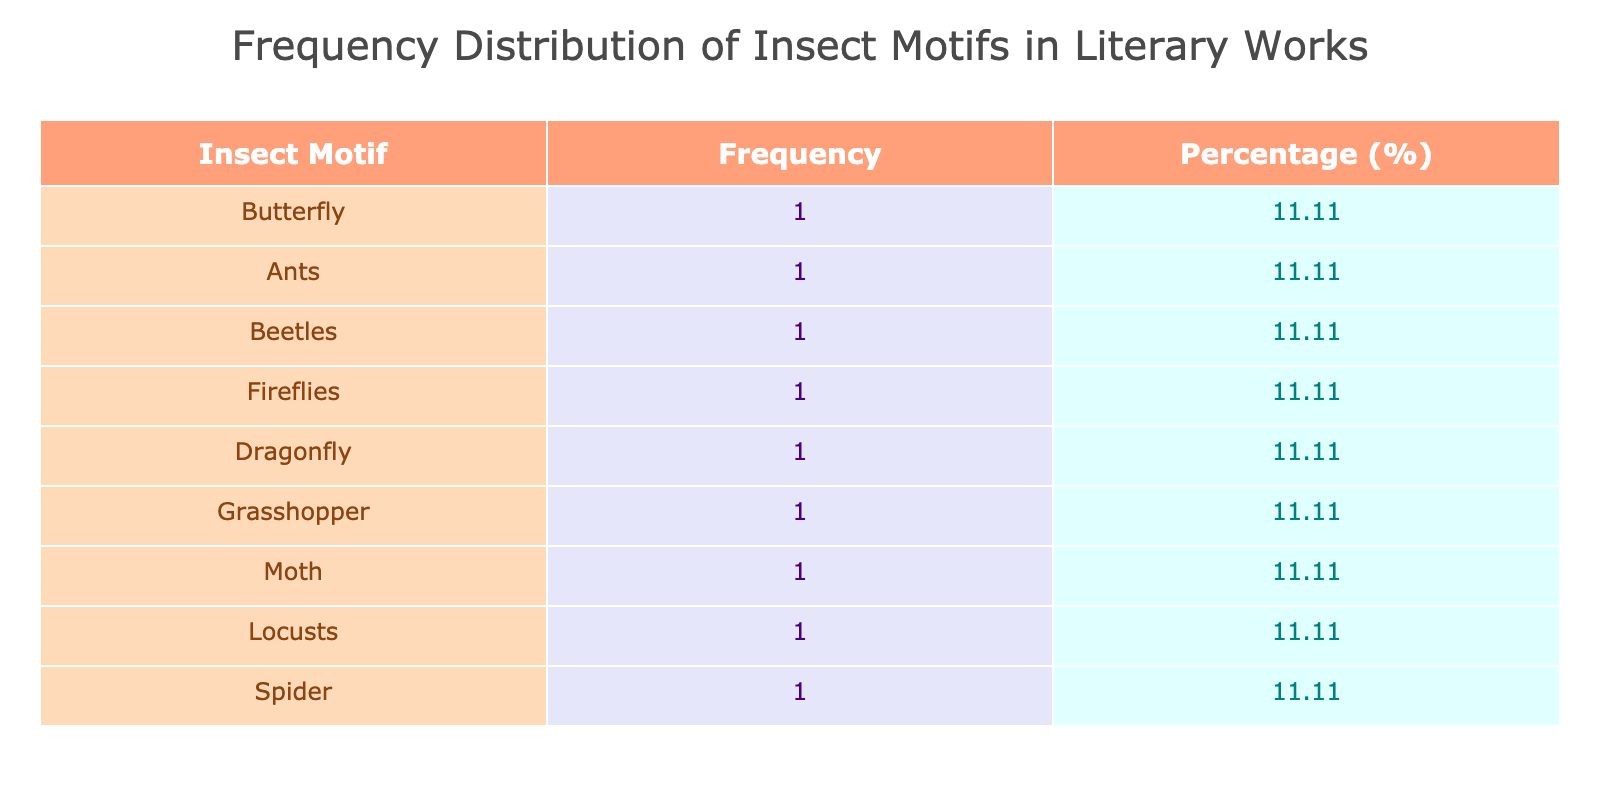What insect motif appears most frequently in literary works? By looking at the table, we can see the frequency column to identify which insect motif has the highest count. Butterfly is listed, with a frequency of 1, but it is tied with several others too.
Answer: Butterfly How many literary works feature the motif of ants? We can directly check the frequency listed for "Ants" in the frequency column. It shows that there is 1 instance of this motif in the literary works.
Answer: 1 Which insect motif is associated with the horror genre? By reviewing the genre column in conjunction with the insect motifs, we find that "Beetles" is the motif linked with the horror genre due to the relevant literary work listed.
Answer: Beetles What is the percentage of literary works that feature dragonflies? The frequency of dragonflies is 1, and the total number of works listed is 8. To get the percentage, we calculate (1/8) * 100 = 12.5%.
Answer: 12.5% Was there any literary work published before 1900 that includes insect motifs? Reviewing the publication year column reveals that "The Beetle" published in 1897 features an insect motif, confirming that works did exist before 1900.
Answer: Yes What is the cumulative frequency of works featuring butterflies and moths? The frequency for "Butterfly" is 1 and for "Moth" is also 1. By adding these frequencies together, we see that the cumulative frequency is 1 + 1 = 2.
Answer: 2 How many genres include the use of insect motifs at least twice? By reviewing the frequency and seeing which motifs and genres contain more than one reference, we find that most genres only have single representations. It appears that none of the genres repeat insect motifs, leading to a total of 0 genres.
Answer: 0 What is the difference in frequency between spider and fireflies motifs? The frequency for "Spider" is 1 and for "Fireflies" is also 1. The difference between these is 1 - 1 = 0.
Answer: 0 Which insect motif corresponds to the latest publication year and what year is it? By checking the publication year column, "Moth" from 2006 lists as the latest work with an insect motif, making it the answer.
Answer: Moth, 2006 How many unique insect motifs are represented in total? Evaluating the list of insect motifs, we see there are 8 distinct ones that appear in the data.
Answer: 8 